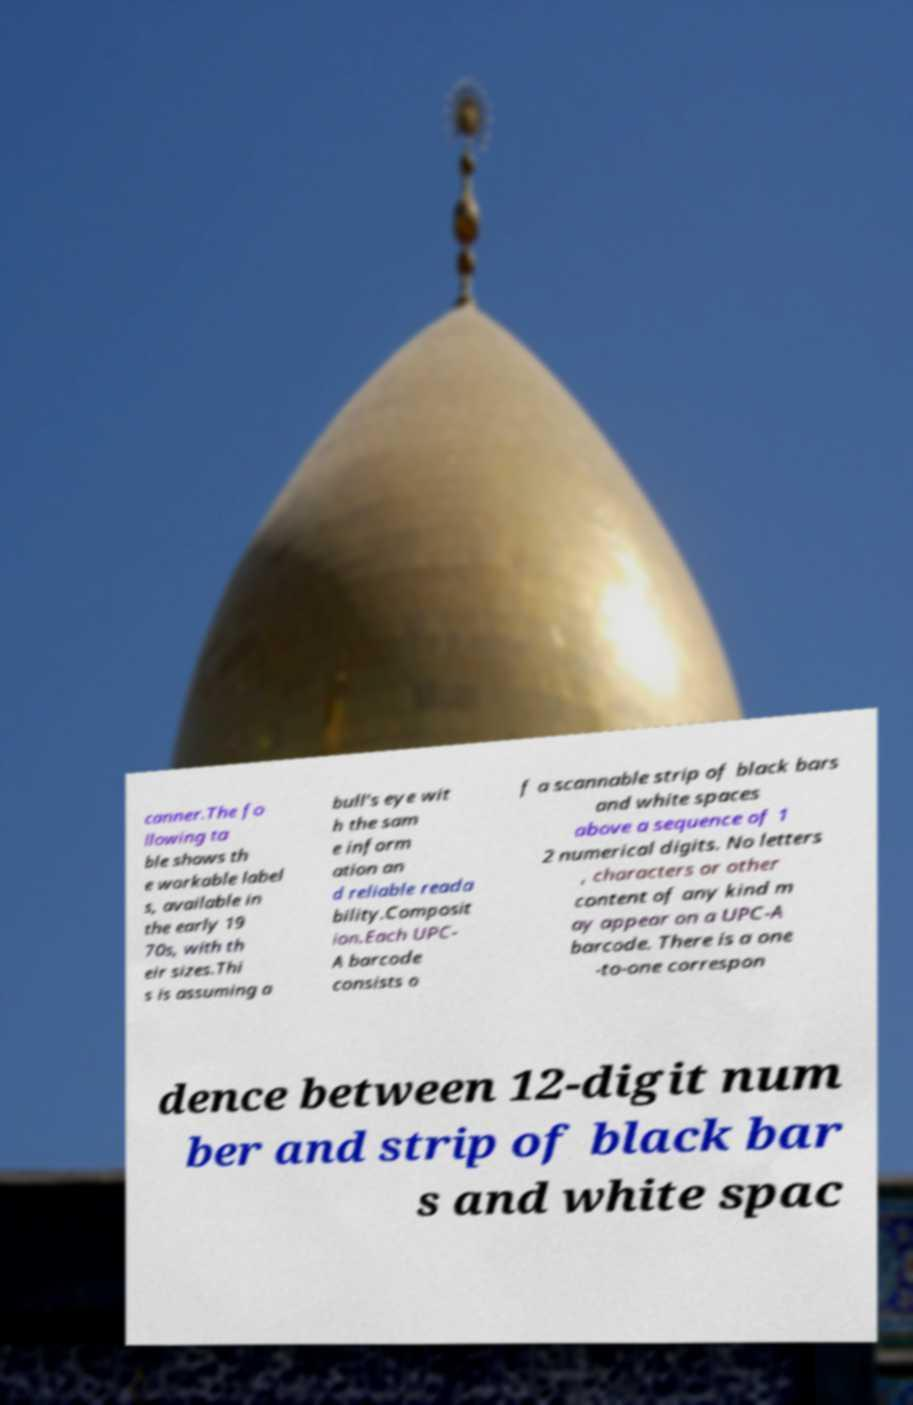Please identify and transcribe the text found in this image. canner.The fo llowing ta ble shows th e workable label s, available in the early 19 70s, with th eir sizes.Thi s is assuming a bull's eye wit h the sam e inform ation an d reliable reada bility.Composit ion.Each UPC- A barcode consists o f a scannable strip of black bars and white spaces above a sequence of 1 2 numerical digits. No letters , characters or other content of any kind m ay appear on a UPC-A barcode. There is a one -to-one correspon dence between 12-digit num ber and strip of black bar s and white spac 